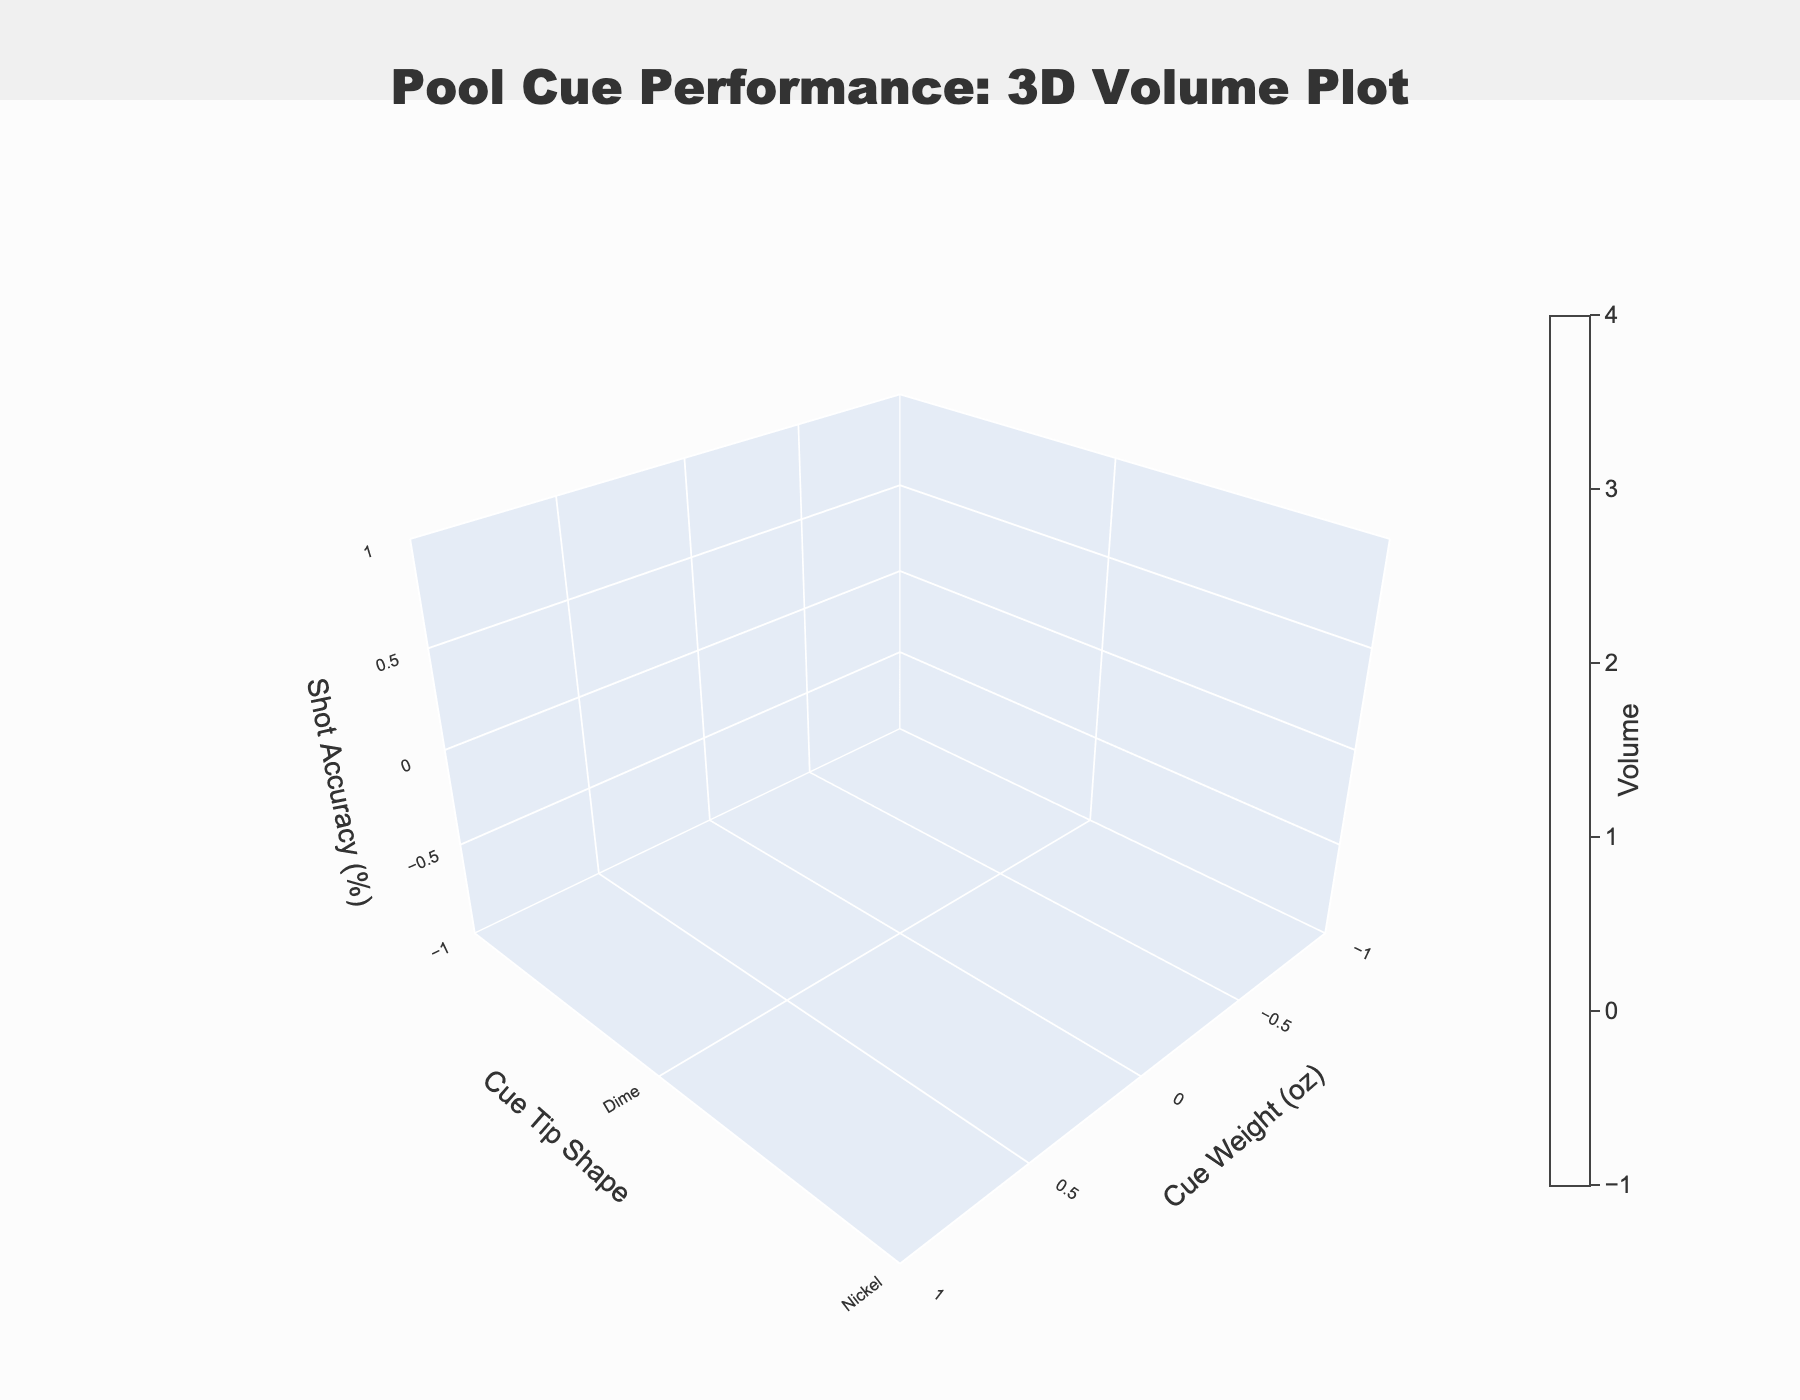What's the title of the figure? The title is usually located at the top of the figure. Here, it reads "Pool Cue Performance: 3D Volume Plot".
Answer: Pool Cue Performance: 3D Volume Plot What are the axis labels? The labels for each axis are written next to the corresponding axis. They are "Cue Weight (oz)" on the x-axis, "Cue Tip Shape" on the y-axis, and "Shot Accuracy (%)" on the z-axis.
Answer: Cue Weight (oz), Cue Tip Shape, Shot Accuracy (%) Which cue tip shape generally shows the highest shot accuracy based on the plot? By inspecting the plot, look for which cue tip shape (labeled on the y-axis) corresponds to the highest values on the z-axis (Shot Accuracy %). The Dime shape consistently shows higher shot accuracy values.
Answer: Dime What is the cue weight range displayed in the plot? The cue weights are plotted on the x-axis. Observing this axis, it ranges from 18 ounces to 22 ounces.
Answer: 18 to 22 ounces How does shot accuracy change with cue weight for the Dime tip shape? Trace the data points on the z-axis (Shot Accuracy %) for the cue tip shape 'Dime' along the x-axis (Cue Weight). The shot accuracy increases from 82% at 18 ounces to a peak value of 85% at 20 ounces and then slightly decreases.
Answer: Increases to a peak at 20 oz, then slightly decreases For the cue weight of 19 ounces, which cue tip shape provides the highest shot accuracy? Locate the x-axis value 19 ounces, then compare the z-axis values for each y-axis category (Dime, Nickel, Quarter). The Dime shape has the highest accuracy at 84%.
Answer: Dime Between the Nickel and Quarter shapes, which one shows better shot accuracy for a cue weight of 21 ounces? Focus on the data points for the cue weight of 21 ounces and compare the shot accuracy values for Nickel and Quarter shapes. Nickel shows 79%, while Quarter shows 76%.
Answer: Nickel Is there a cue tip and weight combination which achieves at least 85% shot accuracy? Look for data points on the plot where the z-axis (Shot Accuracy %) reaches or exceeds 85%. The Dime tip at a cue weight of 20 ounces achieves this.
Answer: Dime at 20 ounces What can be inferred about shot accuracy when using a Quarter tip shape when incrementing cue weight from 18 oz to 22 oz? Observe the trend of shot accuracy (z-axis) for the Quarter tip shape (y-axis) as the cue weight (x-axis) increases. It starts from 75% at 18 oz and progressively increases to 76%, peaking slightly lower compared to other shapes.
Answer: Generally increases slightly How does the volume intensity vary across different cue weights and tip shapes? The volume intensity is depicted using a color gradient. By examining the colors ranging from least intense (light colors) to most intense (dark colors) for different cue weight and tip shape combinations, we see higher volumes for heavier weights and Dime tips.
Answer: Higher for heavier weights and Dime tips 